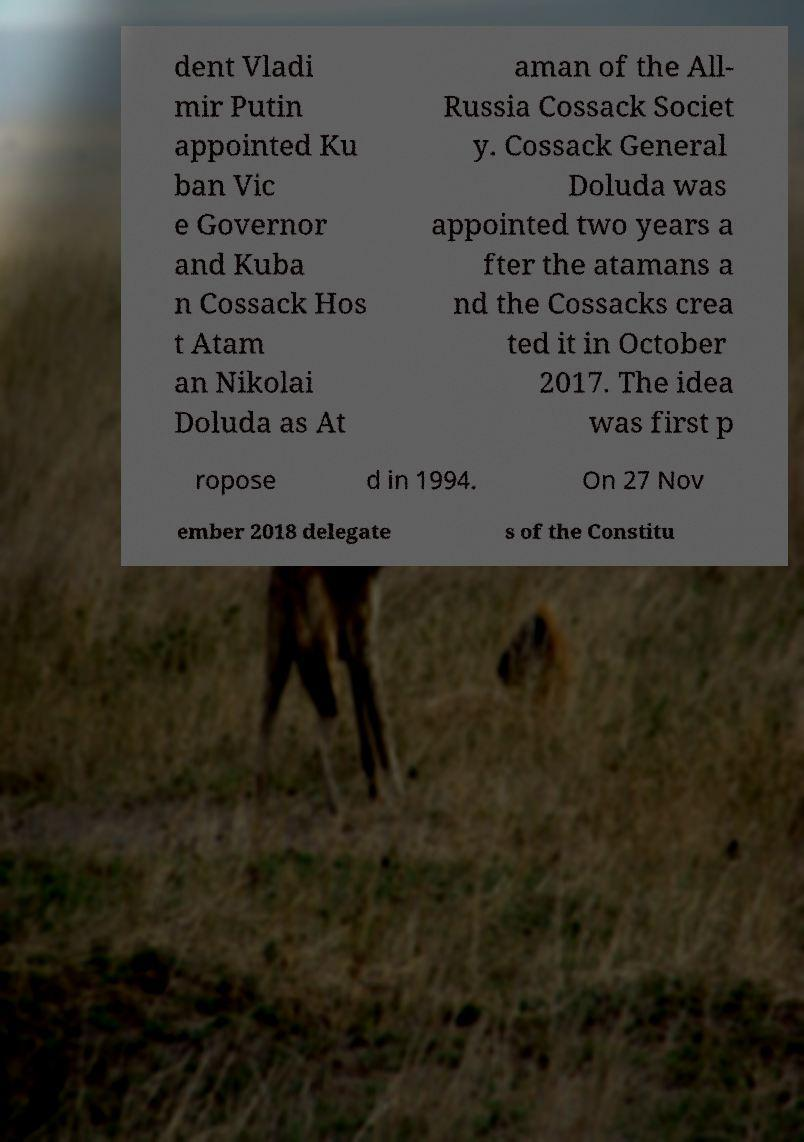Please read and relay the text visible in this image. What does it say? dent Vladi mir Putin appointed Ku ban Vic e Governor and Kuba n Cossack Hos t Atam an Nikolai Doluda as At aman of the All- Russia Cossack Societ y. Cossack General Doluda was appointed two years a fter the atamans a nd the Cossacks crea ted it in October 2017. The idea was first p ropose d in 1994. On 27 Nov ember 2018 delegate s of the Constitu 